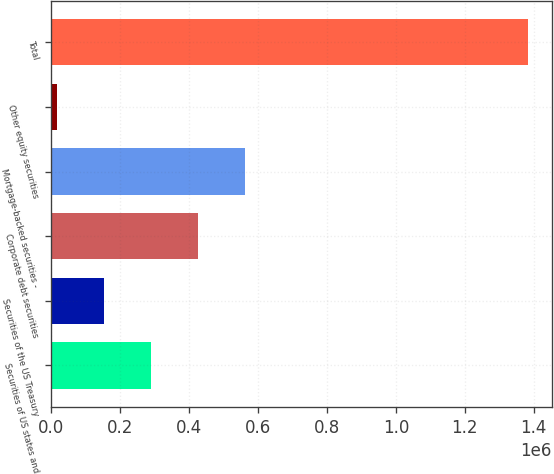<chart> <loc_0><loc_0><loc_500><loc_500><bar_chart><fcel>Securities of US states and<fcel>Securities of the US Treasury<fcel>Corporate debt securities<fcel>Mortgage-backed securities -<fcel>Other equity securities<fcel>Total<nl><fcel>289938<fcel>153236<fcel>426640<fcel>563342<fcel>16534<fcel>1.38355e+06<nl></chart> 